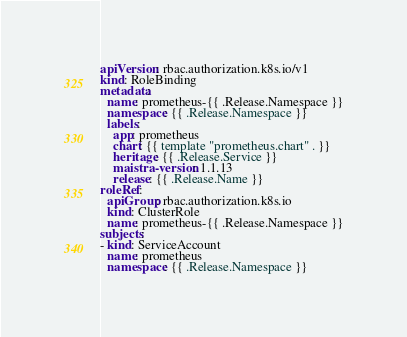Convert code to text. <code><loc_0><loc_0><loc_500><loc_500><_YAML_>apiVersion: rbac.authorization.k8s.io/v1
kind: RoleBinding
metadata:
  name: prometheus-{{ .Release.Namespace }}
  namespace: {{ .Release.Namespace }}
  labels:
    app: prometheus
    chart: {{ template "prometheus.chart" . }}
    heritage: {{ .Release.Service }}
    maistra-version: 1.1.13
    release: {{ .Release.Name }}
roleRef:
  apiGroup: rbac.authorization.k8s.io
  kind: ClusterRole
  name: prometheus-{{ .Release.Namespace }}
subjects:
- kind: ServiceAccount
  name: prometheus
  namespace: {{ .Release.Namespace }}
</code> 